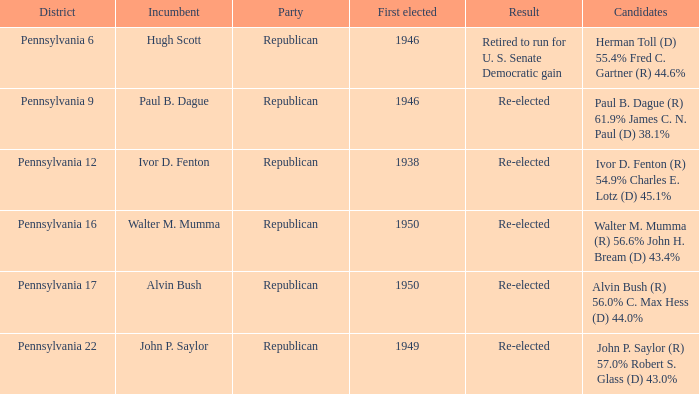How many incumbents come from alvin bush's district? 1.0. 